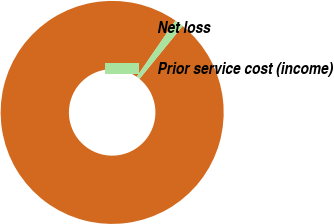<chart> <loc_0><loc_0><loc_500><loc_500><pie_chart><fcel>Net loss<fcel>Prior service cost (income)<nl><fcel>98.71%<fcel>1.29%<nl></chart> 